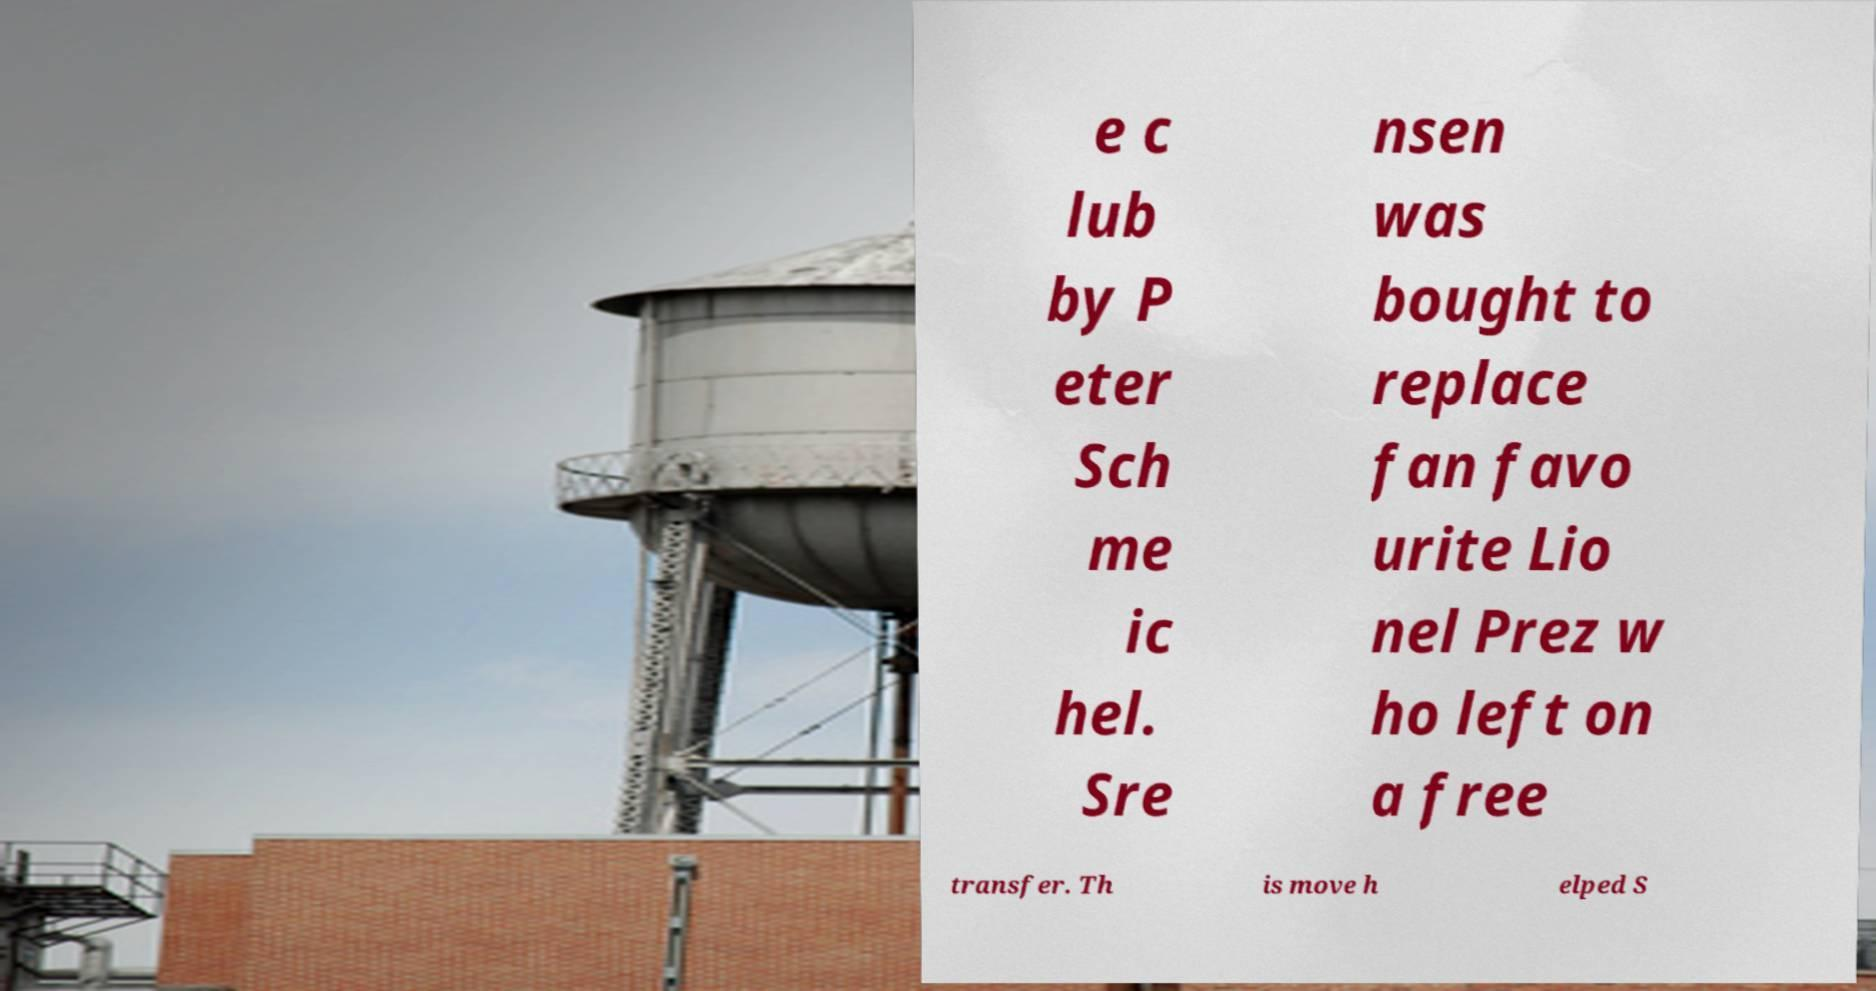Please identify and transcribe the text found in this image. e c lub by P eter Sch me ic hel. Sre nsen was bought to replace fan favo urite Lio nel Prez w ho left on a free transfer. Th is move h elped S 